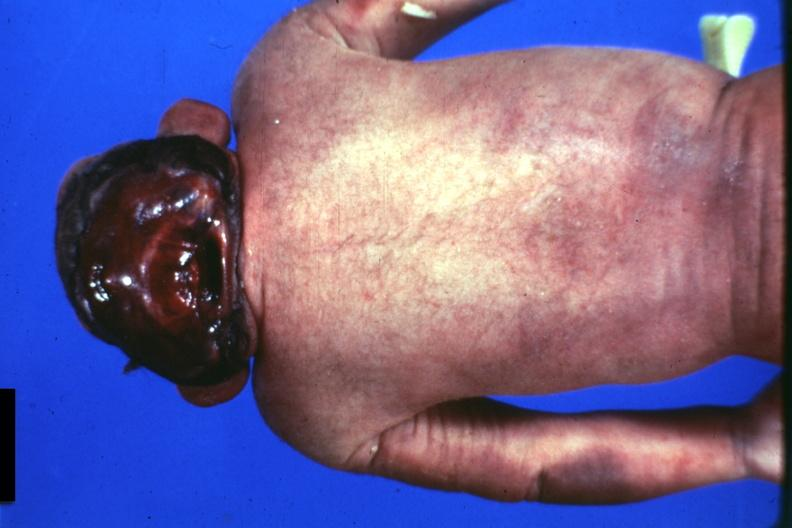does this image show posterior view of typical case?
Answer the question using a single word or phrase. Yes 